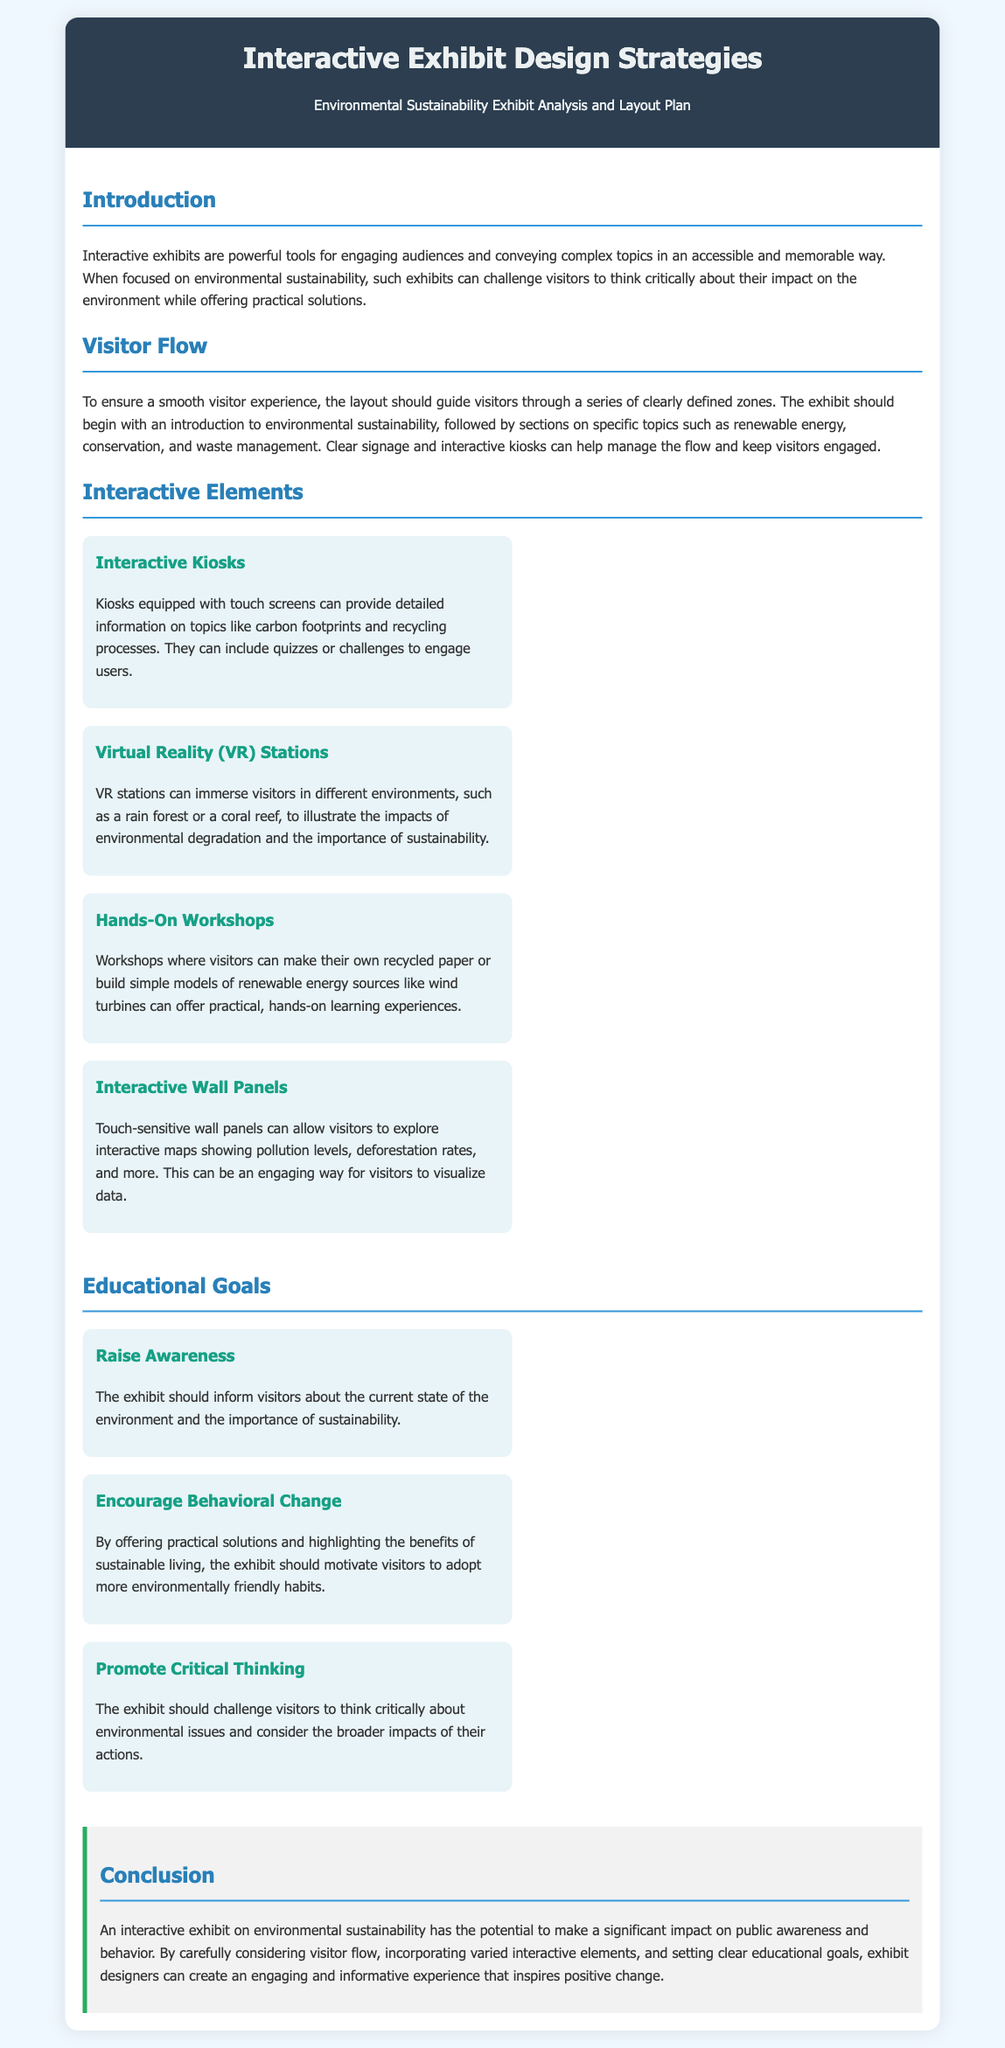What is the title of the homework? The title of the homework is provided in the header section of the document.
Answer: Interactive Exhibit Design Strategies Homework What color is the header background? The header background color is specified in the CSS for the header section.
Answer: Dark blue What are the four interactive elements listed? The interactive elements are described in their own sections, each with a header.
Answer: Interactive Kiosks, Virtual Reality (VR) Stations, Hands-On Workshops, Interactive Wall Panels What is one educational goal of the exhibit? The educational goals are outlined in their own section, providing specific objectives for educational outcomes.
Answer: Raise Awareness How many sections are there in the document? The document is organized into several distinct sections, each with its own heading.
Answer: Five What kind of experiences do hands-on workshops provide? The hands-on workshops are detailed in the interactive elements section, emphasizing the nature of the activities.
Answer: Practical learning experiences What type of flow does the visitor experience follow? The visitor flow is outlined in the Visitor Flow section, detailing how visitors should navigate through the exhibit.
Answer: Smooth and guided What color is the text in the interactive elements section headers? The color for the headers in the interactive elements is defined in the CSS styles for those headings.
Answer: Green What should the exhibit encourage visitors to do? The document states in the educational goals that it aims to influence visitors in a specific way.
Answer: Adopt more environmentally friendly habits 